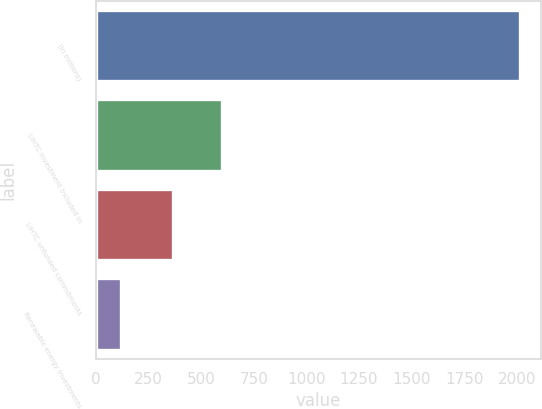Convert chart. <chart><loc_0><loc_0><loc_500><loc_500><bar_chart><fcel>(in millions)<fcel>LIHTC investment included in<fcel>LIHTC unfunded commitments<fcel>Renewable energy investments<nl><fcel>2015<fcel>598<fcel>365<fcel>118<nl></chart> 